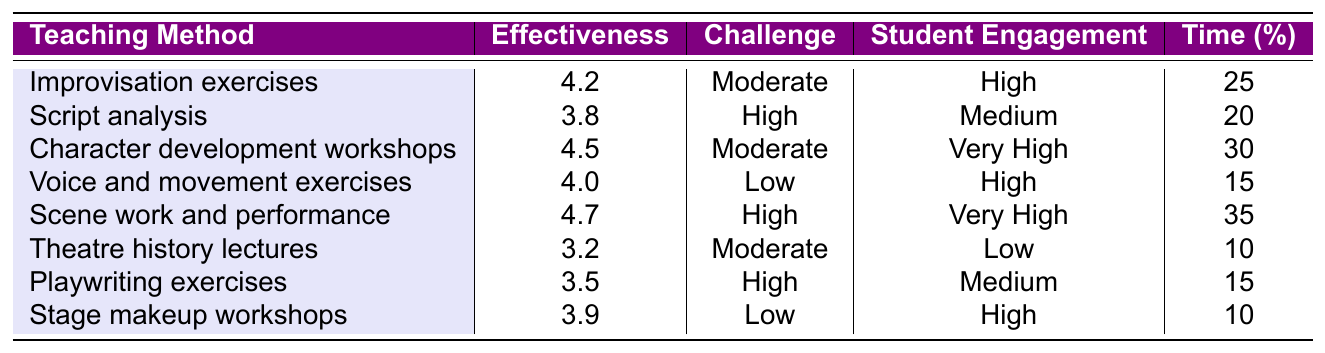What teaching method has the highest effectiveness rating? The table shows that "Scene work and performance" has the highest effectiveness rating of 4.7.
Answer: Scene work and performance What is the challenge level of "Voice and movement exercises"? According to the table, "Voice and movement exercises" are classified as having a Low challenge level.
Answer: Low How much time is allocated for "Theatre history lectures"? The time allocation for "Theatre history lectures" is specified in the table as 10 minutes.
Answer: 10 Which teaching method has both high student engagement and low challenge? The only teaching method with high student engagement and low challenge is "Voice and movement exercises."
Answer: Voice and movement exercises What is the average effectiveness rating of the teaching methods in the table? To find the average, we sum the effectiveness ratings: 4.2 + 3.8 + 4.5 + 4.0 + 4.7 + 3.2 + 3.5 + 3.9 = 31.8. There are 8 methods, so the average is 31.8 / 8 = 3.975.
Answer: 3.975 How many teaching methods have a challenge level categorized as "High"? From the table, "Script analysis," "Scene work and performance," and "Playwriting exercises" are the three methods categorized as High challenge.
Answer: 3 Is there any teaching method that is both very engaging and has a moderate challenge level? Yes, "Character development workshops" is the only method that has very high student engagement and is classified under a moderate challenge level.
Answer: Yes What is the effectiveness rating difference between "Stage makeup workshops" and "Script analysis"? The effectiveness rating for "Stage makeup workshops" is 3.9, and for "Script analysis," it is 3.8. The difference is 3.9 - 3.8 = 0.1.
Answer: 0.1 Which teaching method has the lowest student engagement? The method with the lowest student engagement is "Theatre history lectures," which has a Low engagement rating.
Answer: Theatre history lectures What percentage of time is allocated to "Scene work and performance"? "Scene work and performance" has a time allocation of 35 minutes, so it is 35% of the total time allocated for all methods.
Answer: 35% 